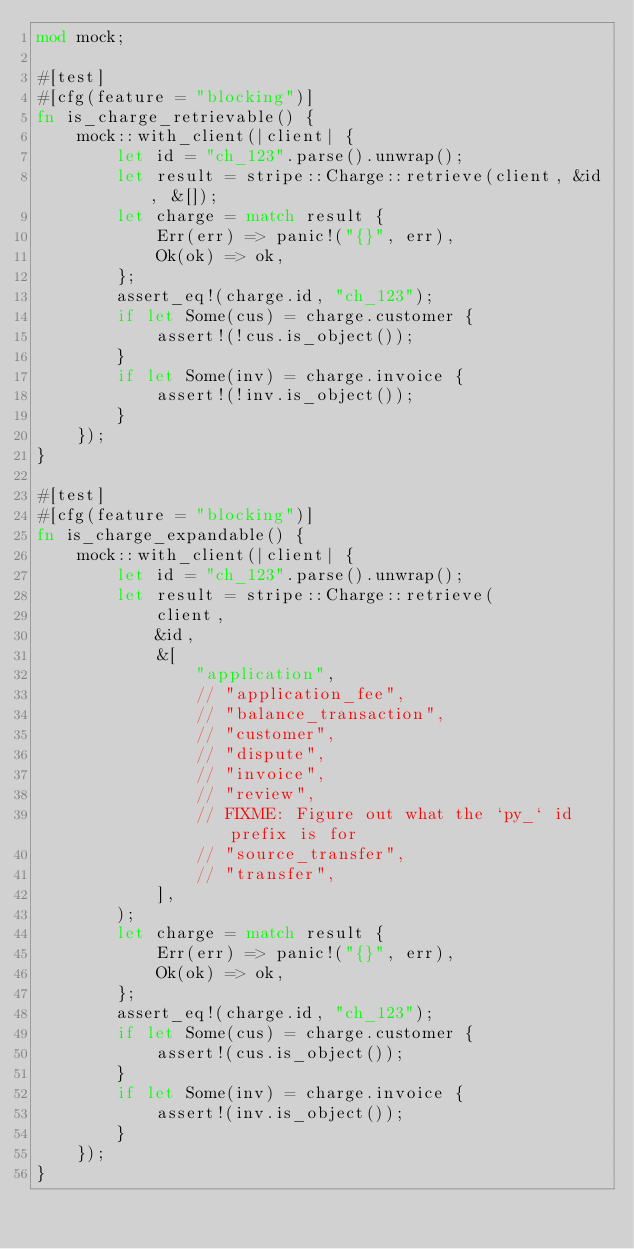<code> <loc_0><loc_0><loc_500><loc_500><_Rust_>mod mock;

#[test]
#[cfg(feature = "blocking")]
fn is_charge_retrievable() {
    mock::with_client(|client| {
        let id = "ch_123".parse().unwrap();
        let result = stripe::Charge::retrieve(client, &id, &[]);
        let charge = match result {
            Err(err) => panic!("{}", err),
            Ok(ok) => ok,
        };
        assert_eq!(charge.id, "ch_123");
        if let Some(cus) = charge.customer {
            assert!(!cus.is_object());
        }
        if let Some(inv) = charge.invoice {
            assert!(!inv.is_object());
        }
    });
}

#[test]
#[cfg(feature = "blocking")]
fn is_charge_expandable() {
    mock::with_client(|client| {
        let id = "ch_123".parse().unwrap();
        let result = stripe::Charge::retrieve(
            client,
            &id,
            &[
                "application",
                // "application_fee",
                // "balance_transaction",
                // "customer",
                // "dispute",
                // "invoice",
                // "review",
                // FIXME: Figure out what the `py_` id prefix is for
                // "source_transfer",
                // "transfer",
            ],
        );
        let charge = match result {
            Err(err) => panic!("{}", err),
            Ok(ok) => ok,
        };
        assert_eq!(charge.id, "ch_123");
        if let Some(cus) = charge.customer {
            assert!(cus.is_object());
        }
        if let Some(inv) = charge.invoice {
            assert!(inv.is_object());
        }
    });
}
</code> 